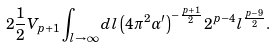Convert formula to latex. <formula><loc_0><loc_0><loc_500><loc_500>2 \frac { 1 } { 2 } V _ { p + 1 } \int _ { l \to \infty } d l \left ( 4 \pi ^ { 2 } \alpha ^ { \prime } \right ) ^ { - \frac { p + 1 } { 2 } } 2 ^ { p - 4 } l ^ { \frac { p - 9 } { 2 } } .</formula> 